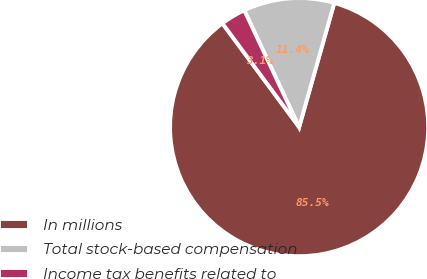Convert chart to OTSL. <chart><loc_0><loc_0><loc_500><loc_500><pie_chart><fcel>In millions<fcel>Total stock-based compensation<fcel>Income tax benefits related to<nl><fcel>85.48%<fcel>11.38%<fcel>3.14%<nl></chart> 